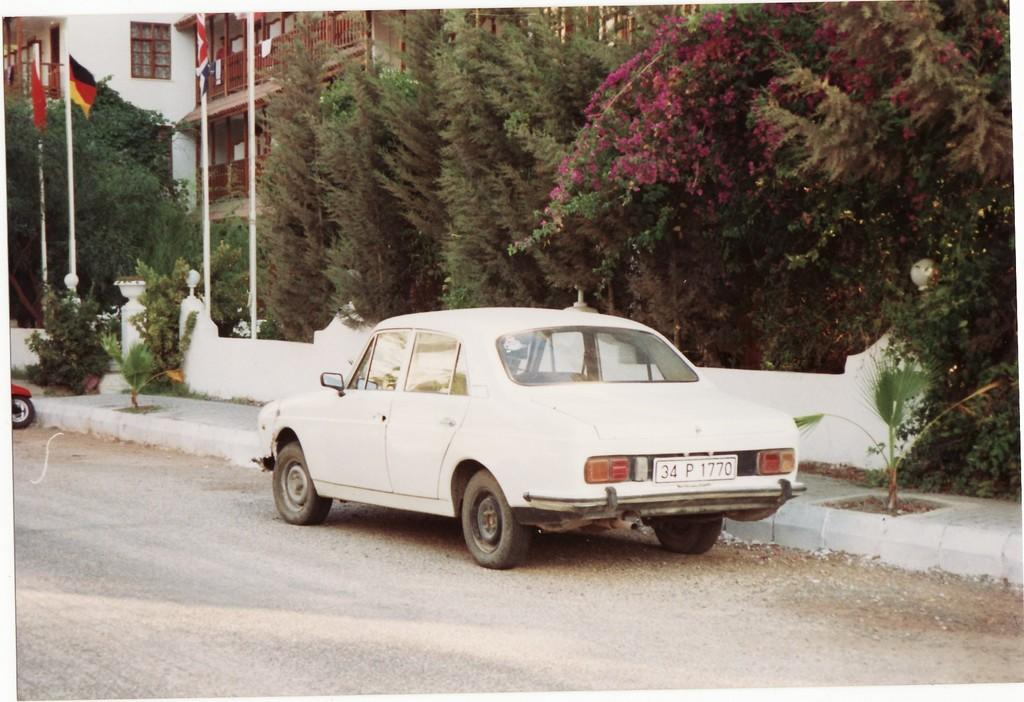What is the main subject of the image? There is a car in the image. What can be seen in the background of the image? There are trees, plants, flowers, flags, and buildings with windows in the image. Can you describe any specific features of the car? There is a wheel visible in the image. What language is the beggar speaking in the image? There is no beggar present in the image, so it is not possible to determine the language being spoken. 